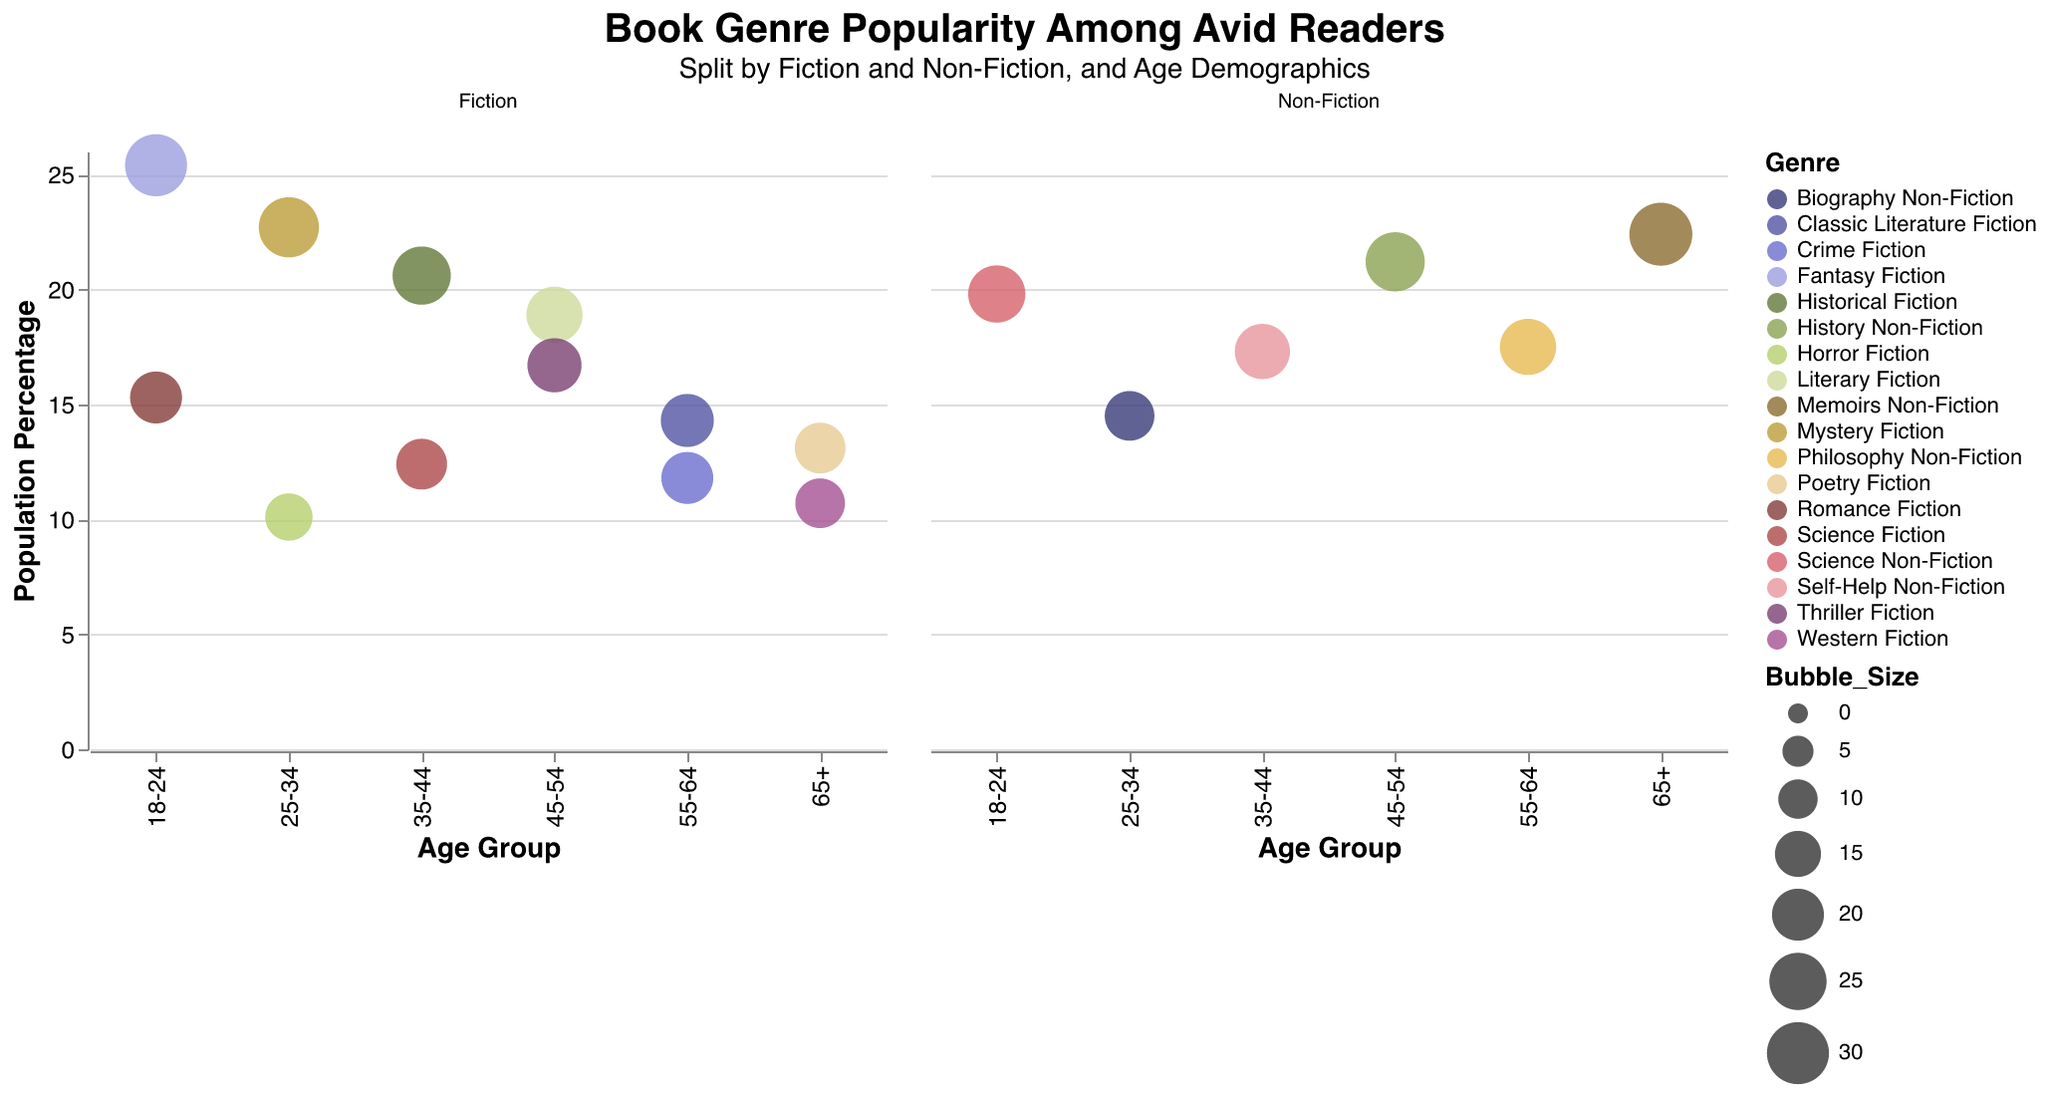What is the most popular Fiction genre among the 18-24 age group? To find the most popular Fiction genre among the 18-24 age group, look at the Fiction data points within this demographic. Fantasy Fiction has the highest Population Percentage at 25.4% compared to Romance Fiction at 15.3%.
Answer: Fantasy Fiction What is the largest bubble in the Non-Fiction category? To identify the largest bubble in the Non-Fiction category, note the Bubble_Size field within the Non-Fiction subplot. Memoirs Non-Fiction in the 65+ age group has the highest Bubble_Size of 31.
Answer: Memoirs Non-Fiction Which Non-Fiction genre is most popular in the 45-54 age group? Look at the Non-Fiction data points in the 45-54 age group. History Non-Fiction has a Population Percentage of 21.2%, which is higher than any other Non-Fiction genre in this age group.
Answer: History Non-Fiction Compare the popularity of Science Fiction among the 35-44 group with the popularity of Horror Fiction among the 25-34 group. Which is more popular? Look at the data points for Science Fiction in the 35-44 age group (Population Percentage of 12.4) and Horror Fiction in the 25-34 age group (Population Percentage of 10.1). Science Fiction is more popular.
Answer: Science Fiction What is the combined Population Percentage of Biography Non-Fiction and History Non-Fiction in their respective age groups? Sum the Population Percentages of Biography Non-Fiction in the 25-34 age group (14.5%) and History Non-Fiction in the 45-54 age group (21.2%). The combined percentage is 14.5 + 21.2.
Answer: 35.7% How many Fiction genres have a Population Percentage higher than 20% across all age groups? Identify all Fiction genres where the Population Percentage is higher than 20%. These are Fantasy Fiction (25.4%) in 18-24, Mystery Fiction (22.7%) in 25-34, Historical Fiction (20.6%) in 35-44. Count these instances.
Answer: 3 Which Fiction genre is least popular among the 65+ age group? Look at the Fiction data points in the 65+ age group and identify the one with the lowest Population Percentage. Western Fiction has the lowest at 10.7%.
Answer: Western Fiction Among the age groups, which has the highest representation in Non-Fiction genres? Check the Bubble_Size for each Non-Fiction genre across age groups. Memoirs Non-Fiction in the 65+ age group has the highest Bubble_Size of 31, indicating the highest representation.
Answer: 65+ What's the difference in Population Percentage between Philosophy Non-Fiction and Self-Help Non-Fiction in their respective age groups? Subtract the Population Percentage of Self-Help Non-Fiction in the 35-44 age group (17.3%) from Philosophy Non-Fiction in the 55-64 age group (17.5%). The difference is 17.5 - 17.3.
Answer: 0.2% 